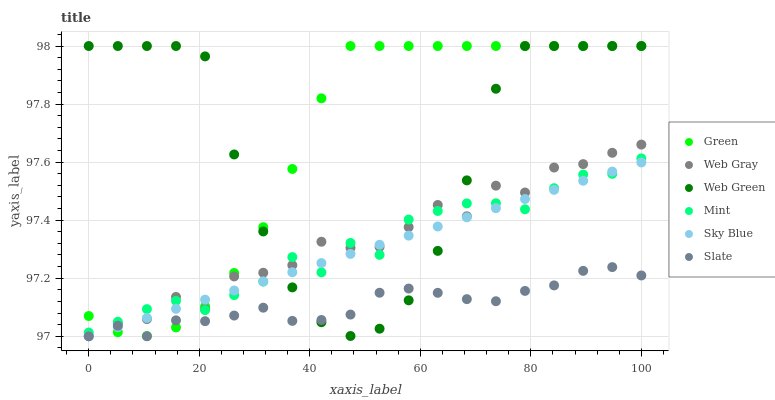Does Slate have the minimum area under the curve?
Answer yes or no. Yes. Does Green have the maximum area under the curve?
Answer yes or no. Yes. Does Web Green have the minimum area under the curve?
Answer yes or no. No. Does Web Green have the maximum area under the curve?
Answer yes or no. No. Is Sky Blue the smoothest?
Answer yes or no. Yes. Is Web Gray the roughest?
Answer yes or no. Yes. Is Slate the smoothest?
Answer yes or no. No. Is Slate the roughest?
Answer yes or no. No. Does Web Gray have the lowest value?
Answer yes or no. Yes. Does Web Green have the lowest value?
Answer yes or no. No. Does Green have the highest value?
Answer yes or no. Yes. Does Slate have the highest value?
Answer yes or no. No. Is Slate less than Mint?
Answer yes or no. Yes. Is Mint greater than Slate?
Answer yes or no. Yes. Does Sky Blue intersect Web Green?
Answer yes or no. Yes. Is Sky Blue less than Web Green?
Answer yes or no. No. Is Sky Blue greater than Web Green?
Answer yes or no. No. Does Slate intersect Mint?
Answer yes or no. No. 